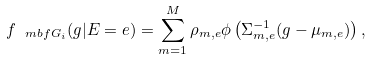Convert formula to latex. <formula><loc_0><loc_0><loc_500><loc_500>f _ { \ m b f { G } _ { i } } ( g | E = e ) = \sum _ { m = 1 } ^ { M } \rho _ { m , e } \phi \left ( \Sigma ^ { - 1 } _ { m , e } ( g - \mu _ { m , e } ) \right ) ,</formula> 